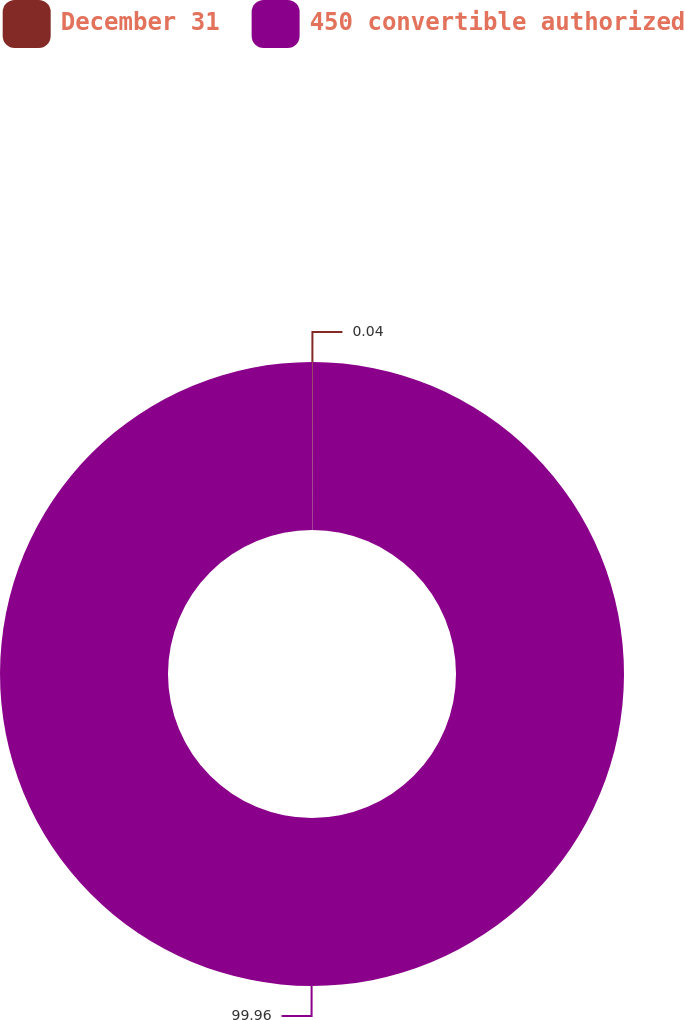Convert chart. <chart><loc_0><loc_0><loc_500><loc_500><pie_chart><fcel>December 31<fcel>450 convertible authorized<nl><fcel>0.04%<fcel>99.96%<nl></chart> 